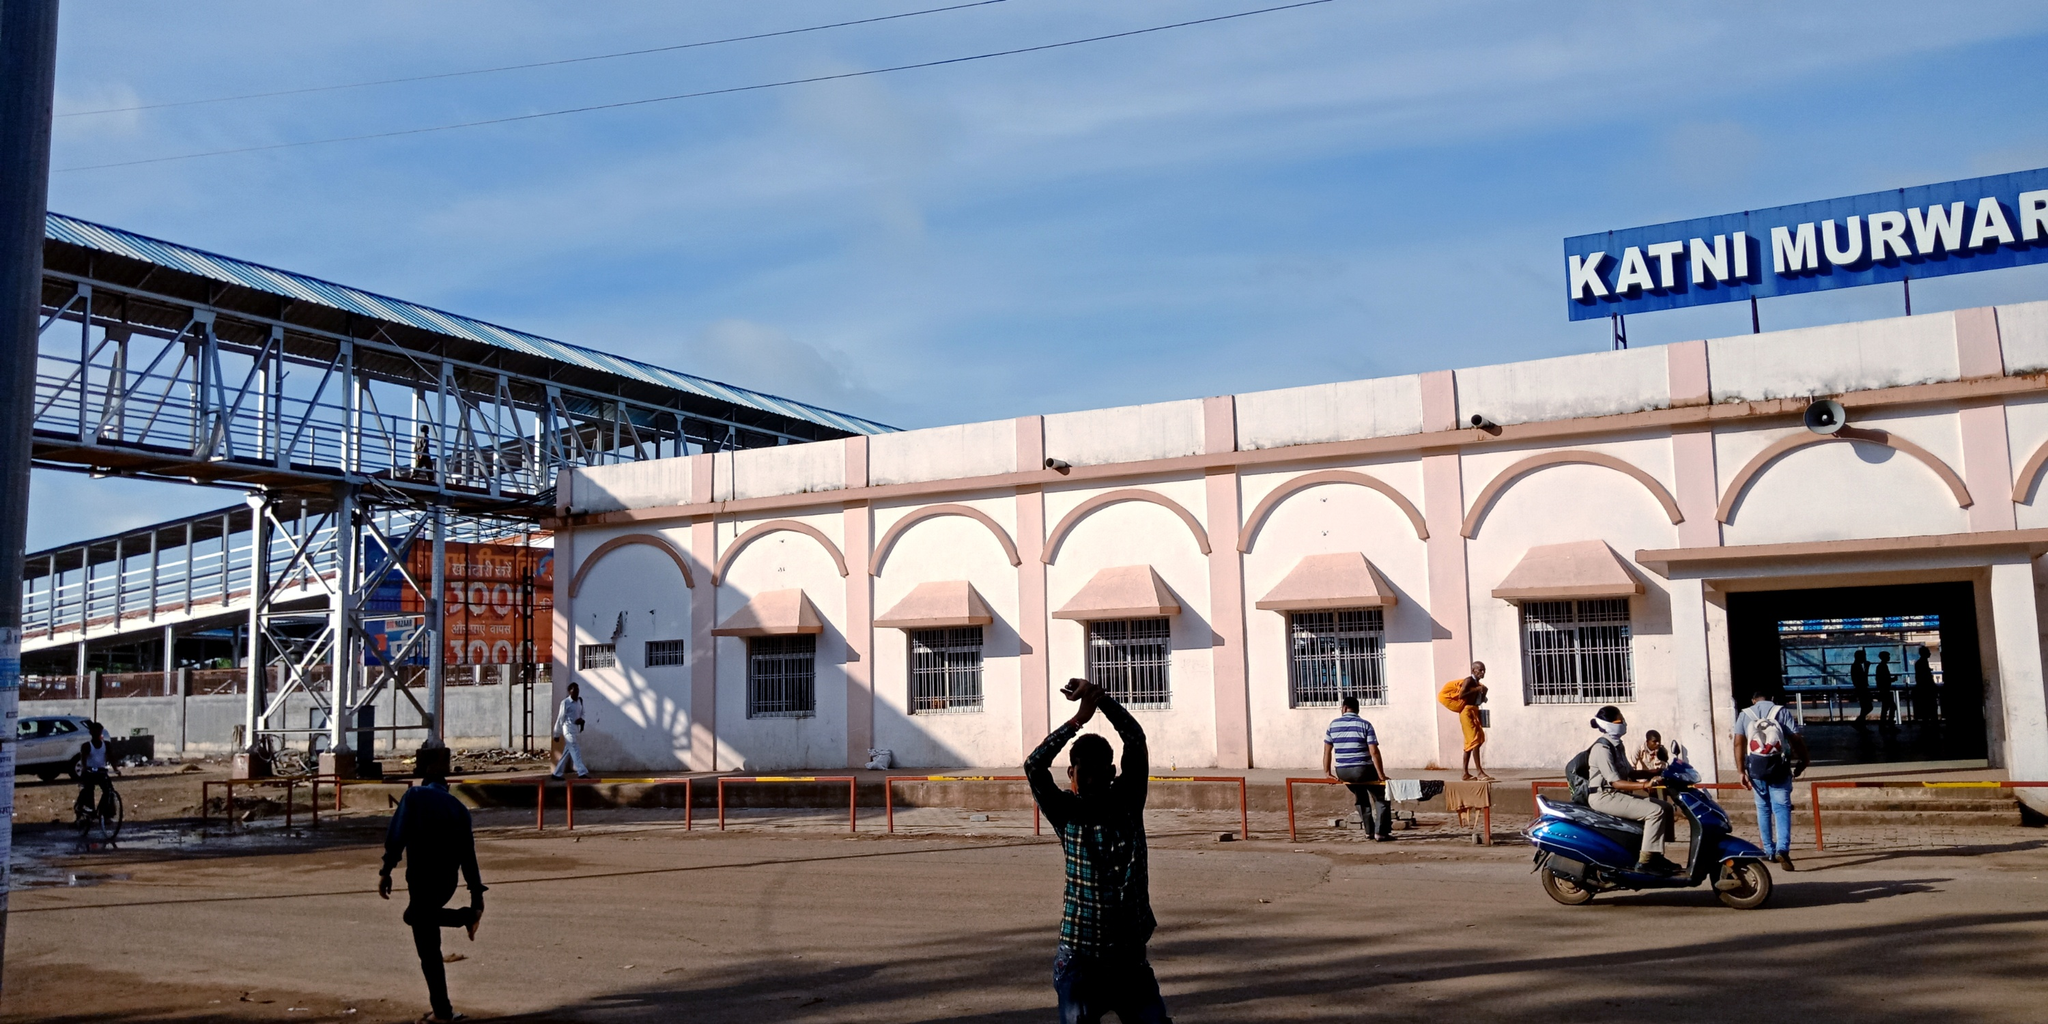How does the infrastructure visible in the image support the function of the station? Visible in the image is a pedestrian bridge that facilitates safe crossing over the tracks, enhancing the functionality and safety of the station. This infrastructure is crucial for managing the flow of passengers, preventing accidents, and ensuring smooth transitions from one platform to another. The presence of safety barriers and clear signage also plays a significant role in guiding commuters and maintaining order. Additionally, ongoing construction work suggests efforts to further improve or expand the station's capabilities to handle more traffic or provide better services. 